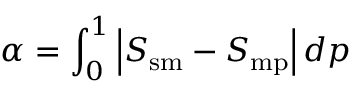<formula> <loc_0><loc_0><loc_500><loc_500>\alpha = \int _ { 0 } ^ { 1 } \left | S _ { s m } - S _ { m p } \right | d p</formula> 